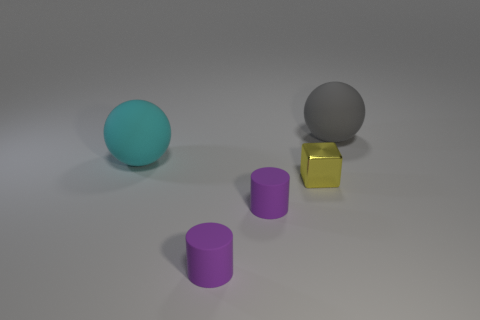Is the material of the large thing that is in front of the gray thing the same as the small cube?
Give a very brief answer. No. How big is the matte ball left of the big object that is to the right of the large cyan sphere?
Ensure brevity in your answer.  Large. There is a object that is behind the yellow block and to the left of the metallic cube; what is its color?
Offer a very short reply. Cyan. What material is the cyan ball that is the same size as the gray sphere?
Your answer should be very brief. Rubber. How many other objects are the same material as the small yellow cube?
Make the answer very short. 0. What shape is the big thing in front of the big matte ball behind the large cyan object?
Your response must be concise. Sphere. Is the material of the gray thing behind the yellow object the same as the yellow thing that is to the left of the big gray rubber thing?
Keep it short and to the point. No. How big is the metallic block that is in front of the large gray object?
Your answer should be compact. Small. There is a big gray object that is the same shape as the big cyan matte thing; what is it made of?
Ensure brevity in your answer.  Rubber. There is a big cyan object that is behind the small yellow block; what is its shape?
Make the answer very short. Sphere. 